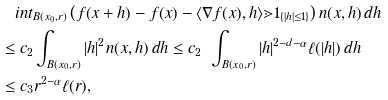Convert formula to latex. <formula><loc_0><loc_0><loc_500><loc_500>& \quad i n t _ { B ( x _ { 0 } , r ) } \left ( f ( x + h ) - f ( x ) - \langle \nabla f ( x ) , h \rangle \mathbb { m } { 1 } _ { \{ | h | \leq 1 \} } \right ) n ( x , h ) \, d h \\ & \leq c _ { 2 } \int _ { B ( x _ { 0 } , r ) } | h | ^ { 2 } n ( x , h ) \, d h \leq c _ { 2 } \ \int _ { B ( x _ { 0 } , r ) } | h | ^ { 2 - d - \alpha } \ell ( | h | ) \, d h \\ & \leq c _ { 3 } r ^ { 2 - \alpha } \ell ( r ) ,</formula> 